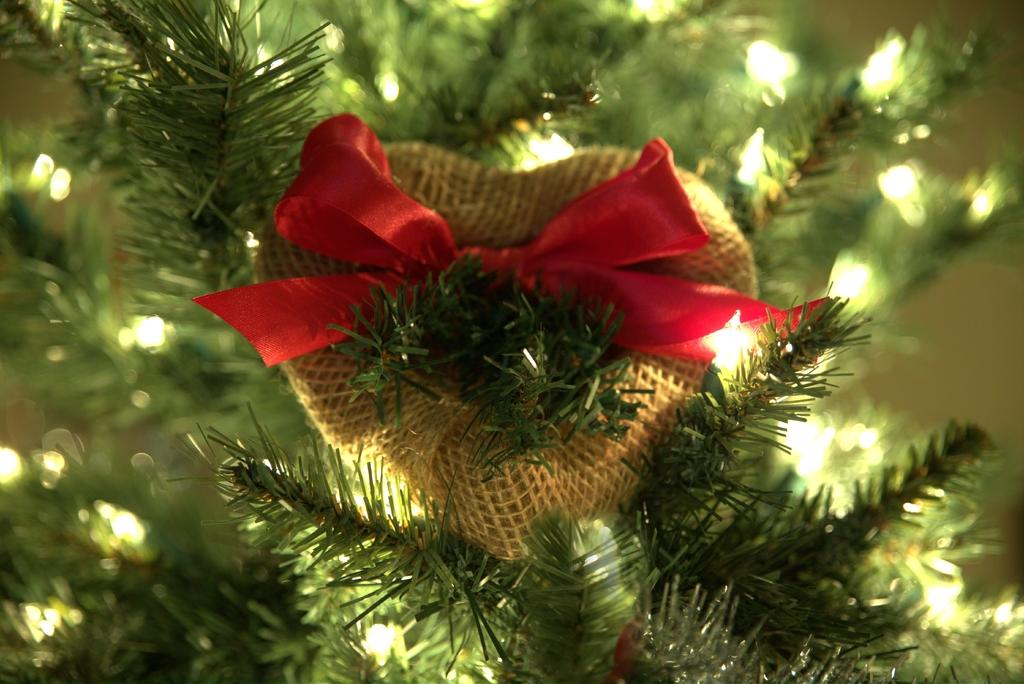What is the object with a red ribbon in the image? The object with a red ribbon is placed on a tree. What can be seen on the tree in the image? The tree has lights. What is the health status of the tree in the image? The provided facts do not mention any information about the health status of the tree, so it cannot be determined from the image. 